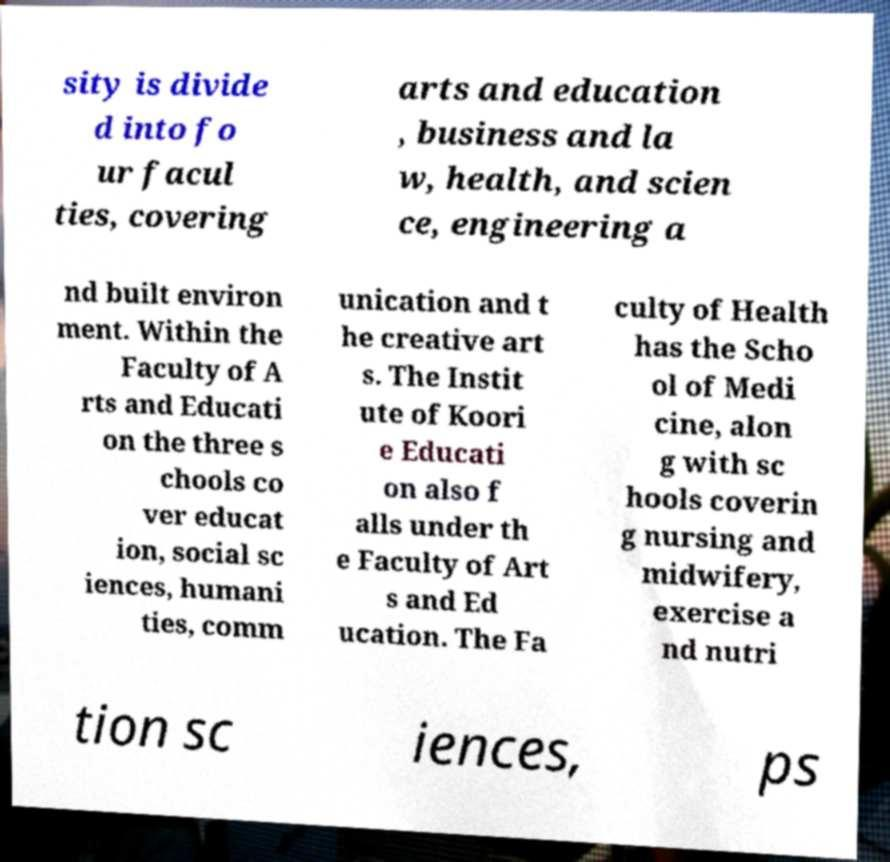Can you read and provide the text displayed in the image?This photo seems to have some interesting text. Can you extract and type it out for me? sity is divide d into fo ur facul ties, covering arts and education , business and la w, health, and scien ce, engineering a nd built environ ment. Within the Faculty of A rts and Educati on the three s chools co ver educat ion, social sc iences, humani ties, comm unication and t he creative art s. The Instit ute of Koori e Educati on also f alls under th e Faculty of Art s and Ed ucation. The Fa culty of Health has the Scho ol of Medi cine, alon g with sc hools coverin g nursing and midwifery, exercise a nd nutri tion sc iences, ps 